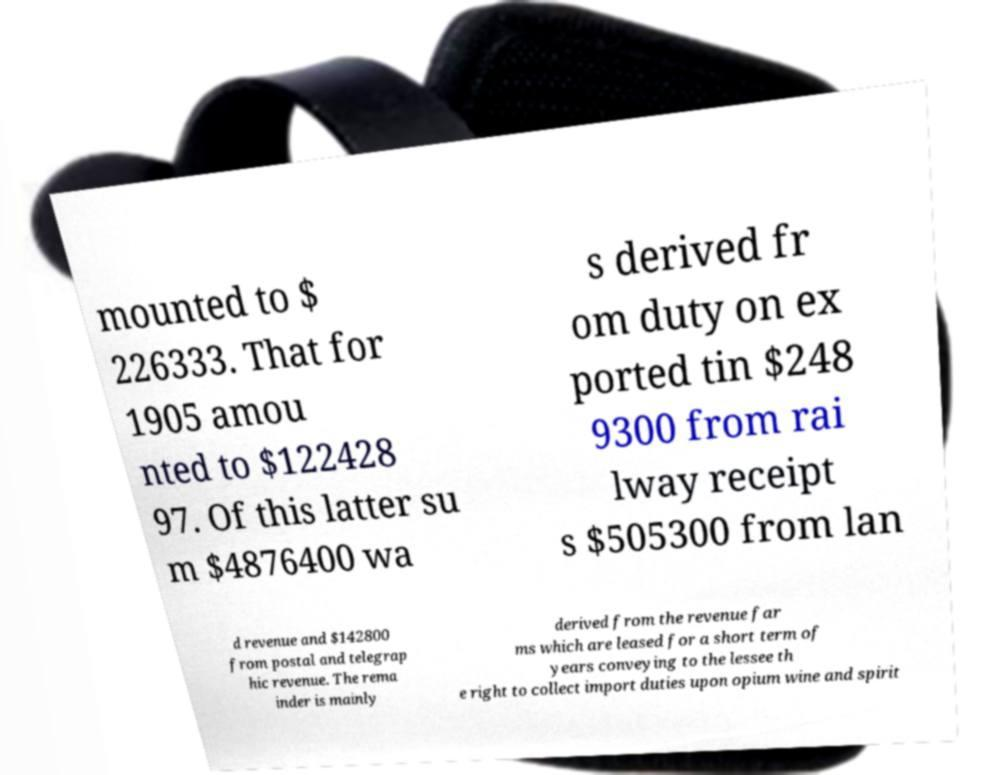Can you accurately transcribe the text from the provided image for me? mounted to $ 226333. That for 1905 amou nted to $122428 97. Of this latter su m $4876400 wa s derived fr om duty on ex ported tin $248 9300 from rai lway receipt s $505300 from lan d revenue and $142800 from postal and telegrap hic revenue. The rema inder is mainly derived from the revenue far ms which are leased for a short term of years conveying to the lessee th e right to collect import duties upon opium wine and spirit 